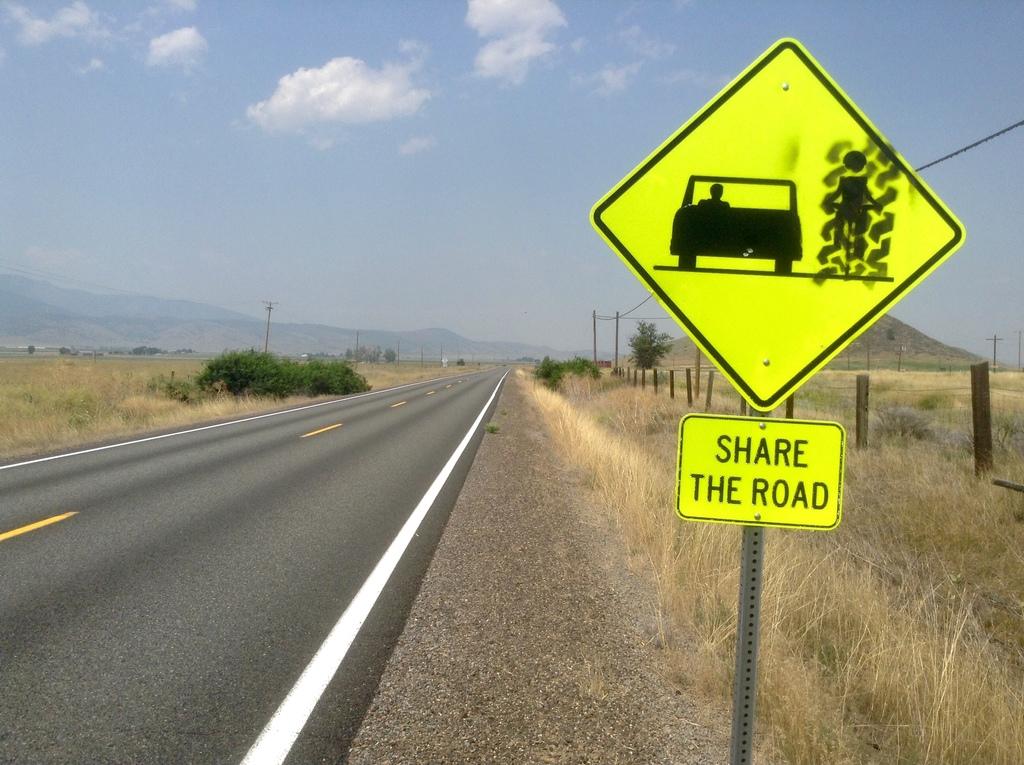What should we do with the road?
Your answer should be very brief. Share. 